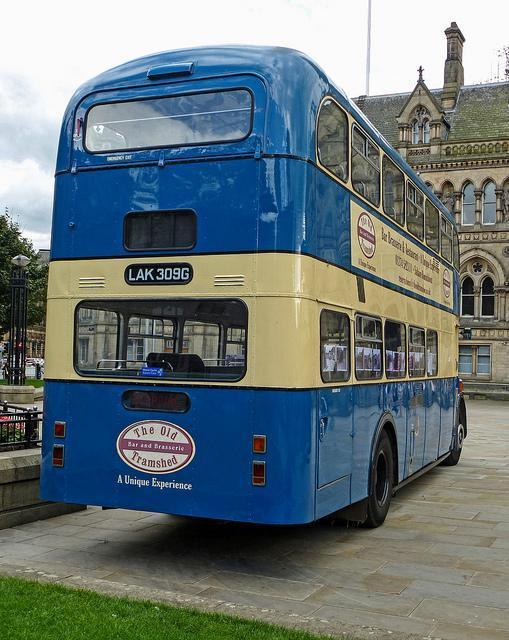How many people are wearing black pants?
Give a very brief answer. 0. 